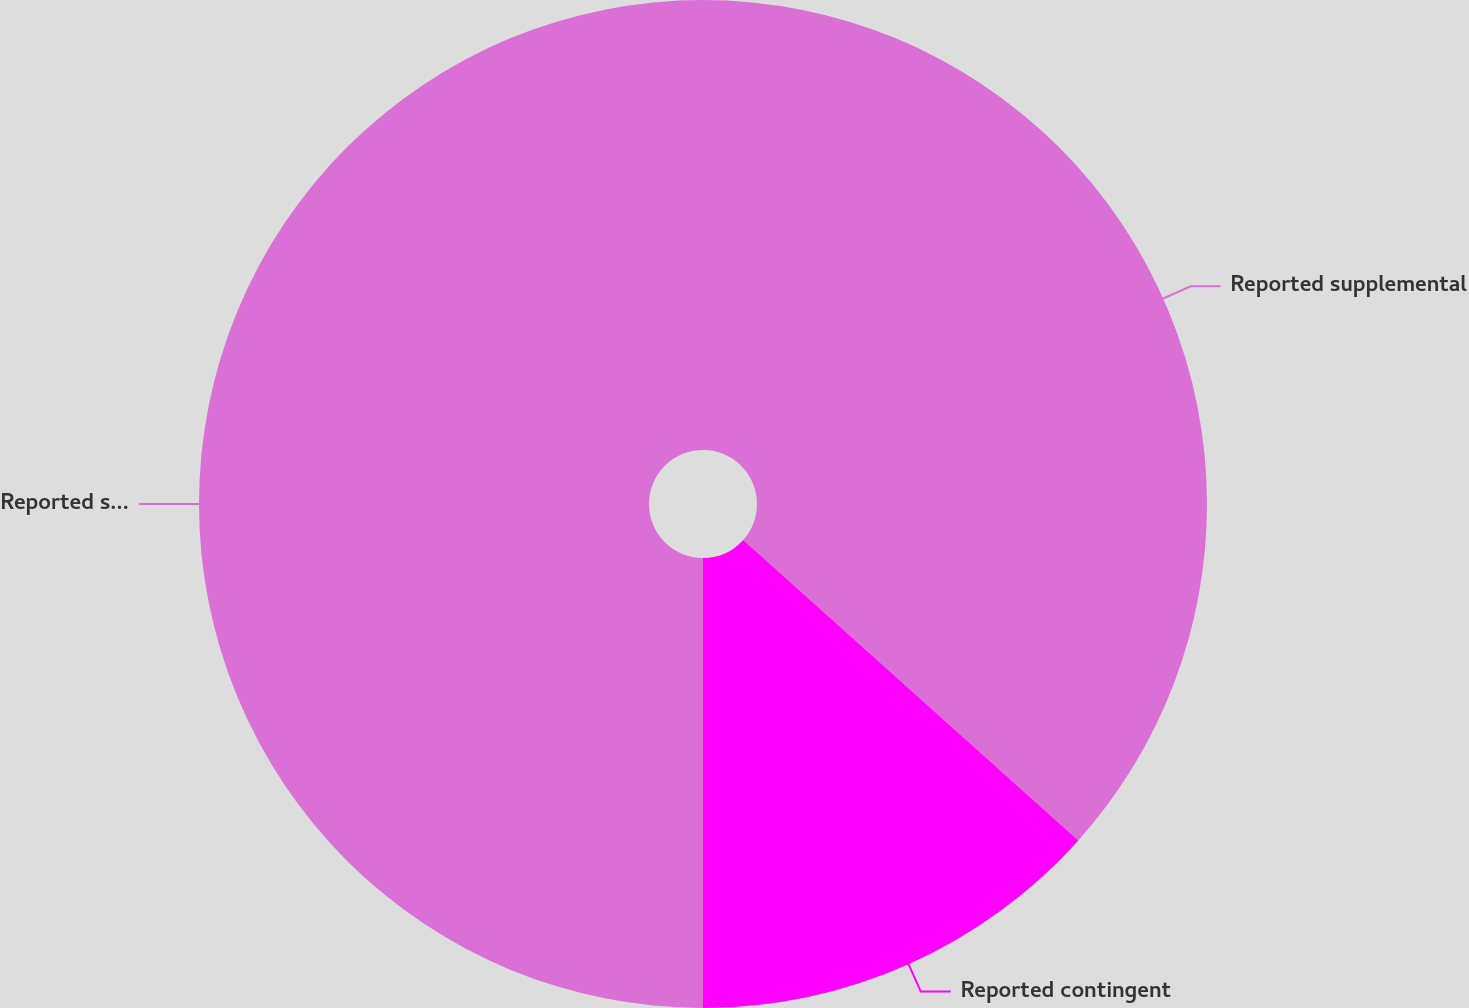<chart> <loc_0><loc_0><loc_500><loc_500><pie_chart><fcel>Reported supplemental<fcel>Reported contingent<fcel>Reported supplemental and<nl><fcel>36.63%<fcel>13.37%<fcel>50.0%<nl></chart> 